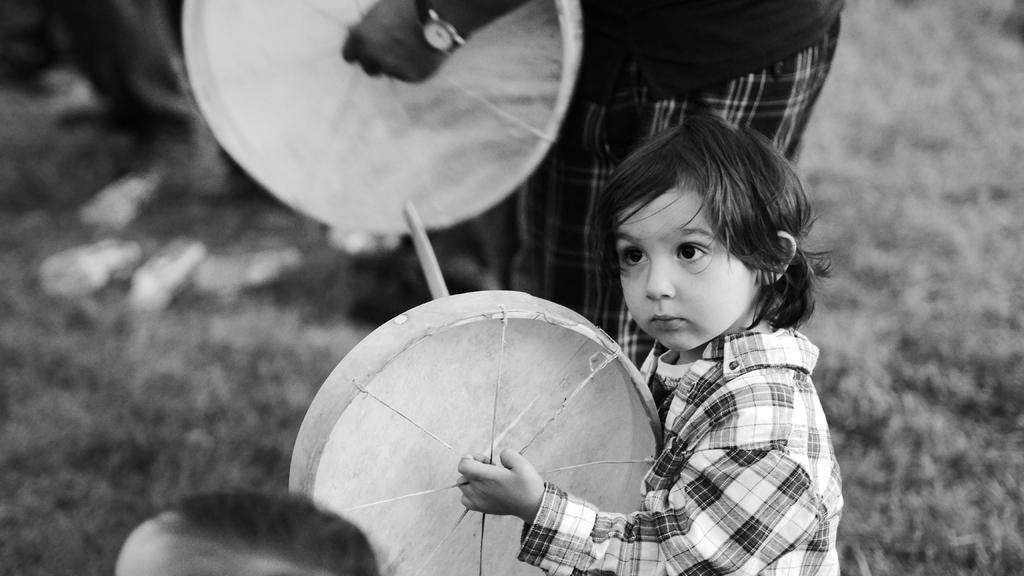What is the boy in the image doing? The boy in the image is playing a drum. Can you describe the actions of the person in the image? The person in the image is playing a drum behind the boy. How many people are playing drums in the image? There are two people playing drums in the image, the boy and the person behind him. What type of chicken is visible in the image? There is no chicken present in the image. What is the boy using to rub the drum in the image? The boy is not rubbing the drum in the image; he is playing it with drumsticks or his hands. 